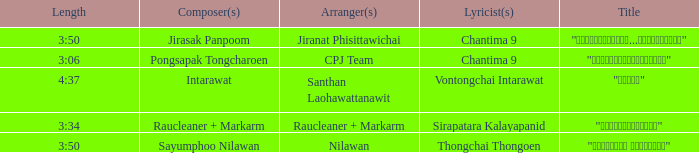Who was the arranger for the song that had a lyricist of Sirapatara Kalayapanid? Raucleaner + Markarm. 